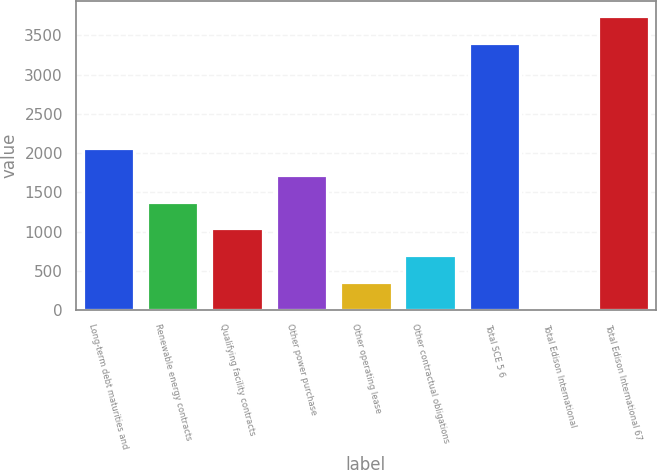Convert chart. <chart><loc_0><loc_0><loc_500><loc_500><bar_chart><fcel>Long-term debt maturities and<fcel>Renewable energy contracts<fcel>Qualifying facility contracts<fcel>Other power purchase<fcel>Other operating lease<fcel>Other contractual obligations<fcel>Total SCE 5 6<fcel>Total Edison International<fcel>Total Edison International 67<nl><fcel>2062<fcel>1380<fcel>1039<fcel>1721<fcel>357<fcel>698<fcel>3410<fcel>16<fcel>3751<nl></chart> 